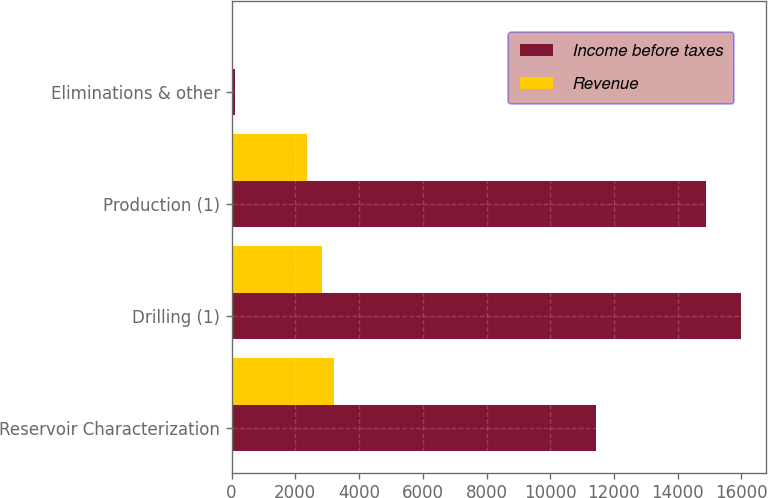Convert chart to OTSL. <chart><loc_0><loc_0><loc_500><loc_500><stacked_bar_chart><ecel><fcel>Reservoir Characterization<fcel>Drilling (1)<fcel>Production (1)<fcel>Eliminations & other<nl><fcel>Income before taxes<fcel>11424<fcel>15971<fcel>14875<fcel>121<nl><fcel>Revenue<fcel>3212<fcel>2824<fcel>2371<fcel>60<nl></chart> 